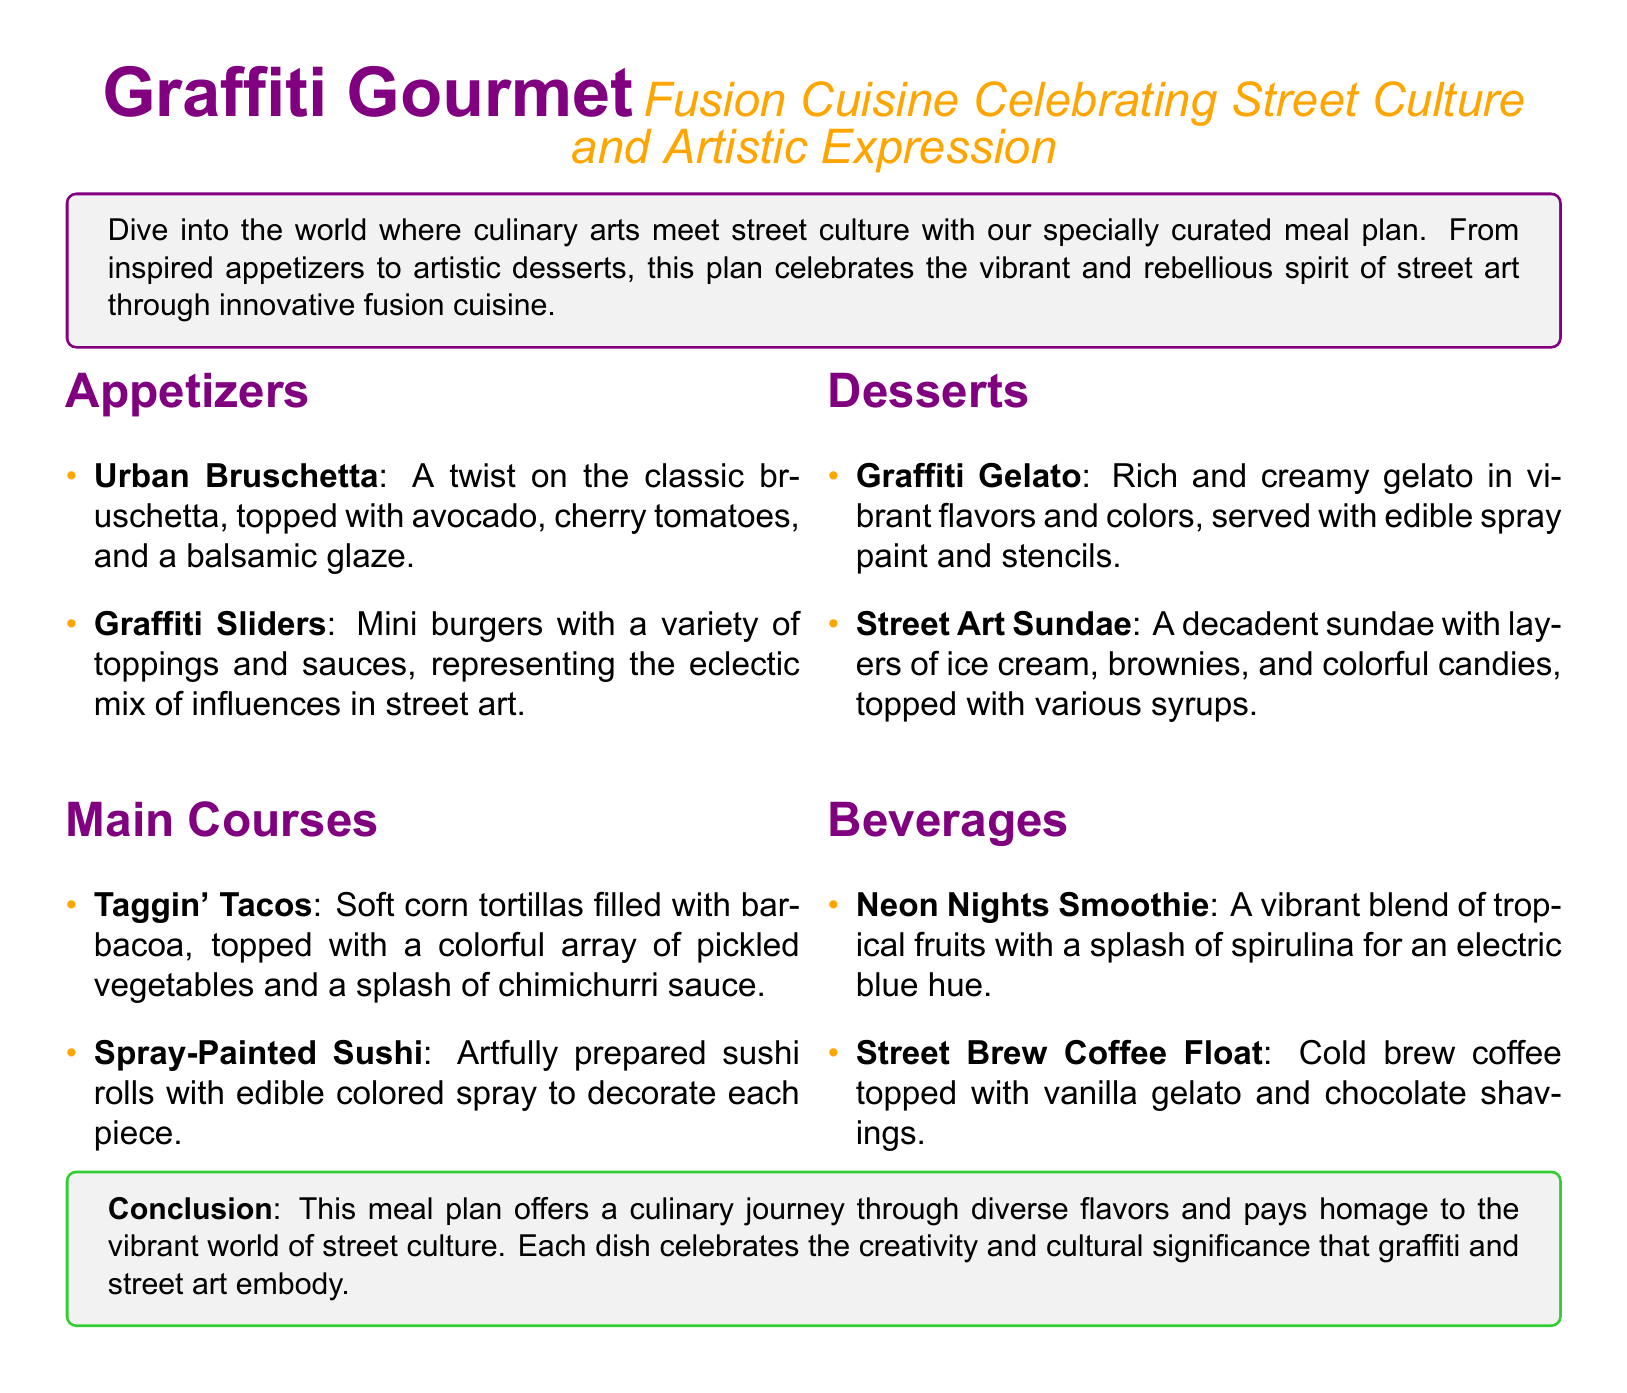What are the appetizers? The appetizers listed in the document are Urban Bruschetta and Graffiti Sliders.
Answer: Urban Bruschetta, Graffiti Sliders What is the first dessert mentioned? The first dessert listed in the document is Graffiti Gelato.
Answer: Graffiti Gelato How many main courses are there? The document lists two main courses: Taggin' Tacos and Spray-Painted Sushi.
Answer: 2 What beverage is described as vibrant? The beverage described as vibrant is the Neon Nights Smoothie.
Answer: Neon Nights Smoothie Which dish features a variety of toppings and sauces? The Graffiti Sliders are described as having a variety of toppings and sauces.
Answer: Graffiti Sliders What color is the Graffiti Gourmet document primarily associated with? The primary color associated with the Graffiti Gourmet document is purple.
Answer: purple How does the meal plan celebrate street culture? The meal plan celebrates street culture through innovative fusion cuisine that reflects the vibrant spirit of street art.
Answer: Innovative fusion cuisine What is included in the Street Art Sundae? The Street Art Sundae includes layers of ice cream, brownies, and colorful candies.
Answer: Ice cream, brownies, colorful candies 